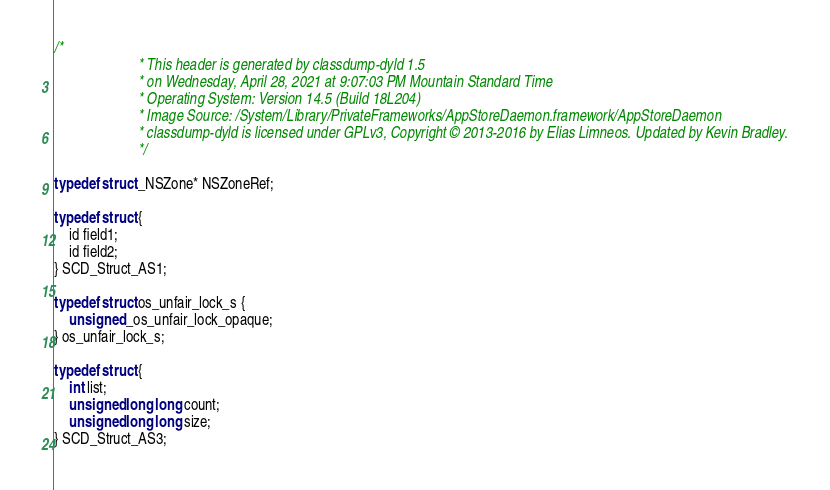<code> <loc_0><loc_0><loc_500><loc_500><_C_>/*
                       * This header is generated by classdump-dyld 1.5
                       * on Wednesday, April 28, 2021 at 9:07:03 PM Mountain Standard Time
                       * Operating System: Version 14.5 (Build 18L204)
                       * Image Source: /System/Library/PrivateFrameworks/AppStoreDaemon.framework/AppStoreDaemon
                       * classdump-dyld is licensed under GPLv3, Copyright © 2013-2016 by Elias Limneos. Updated by Kevin Bradley.
                       */

typedef struct _NSZone* NSZoneRef;

typedef struct {
	id field1;
	id field2;
} SCD_Struct_AS1;

typedef struct os_unfair_lock_s {
	unsigned _os_unfair_lock_opaque;
} os_unfair_lock_s;

typedef struct {
	int list;
	unsigned long long count;
	unsigned long long size;
} SCD_Struct_AS3;

</code> 